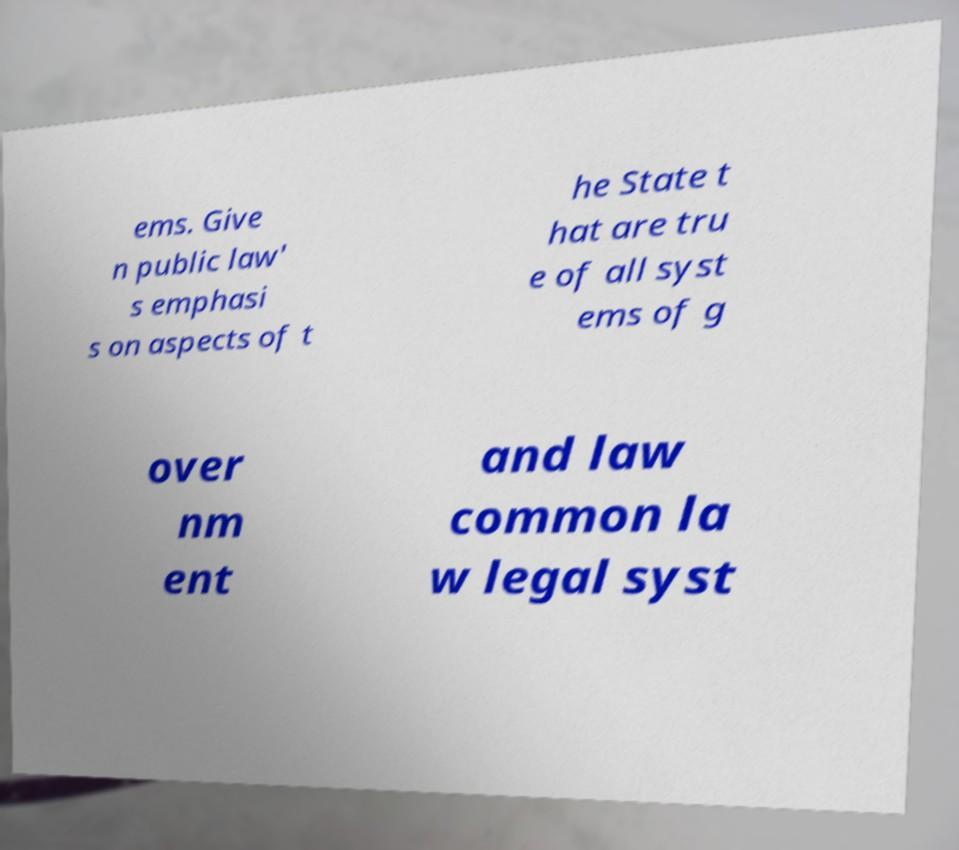Can you accurately transcribe the text from the provided image for me? ems. Give n public law' s emphasi s on aspects of t he State t hat are tru e of all syst ems of g over nm ent and law common la w legal syst 